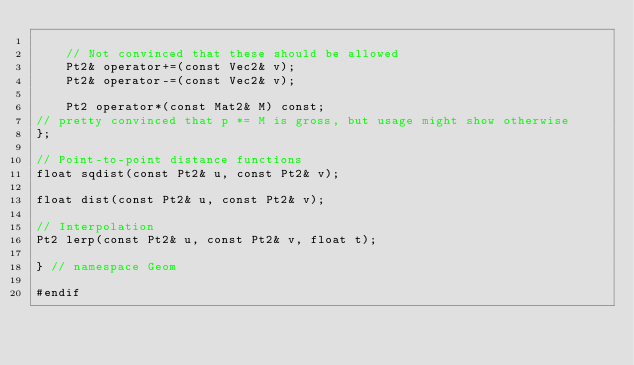<code> <loc_0><loc_0><loc_500><loc_500><_C_>
    // Not convinced that these should be allowed
    Pt2& operator+=(const Vec2& v);
    Pt2& operator-=(const Vec2& v);

    Pt2 operator*(const Mat2& M) const;
// pretty convinced that p *= M is gross, but usage might show otherwise
};

// Point-to-point distance functions
float sqdist(const Pt2& u, const Pt2& v);

float dist(const Pt2& u, const Pt2& v);

// Interpolation
Pt2 lerp(const Pt2& u, const Pt2& v, float t);

} // namespace Geom

#endif
</code> 